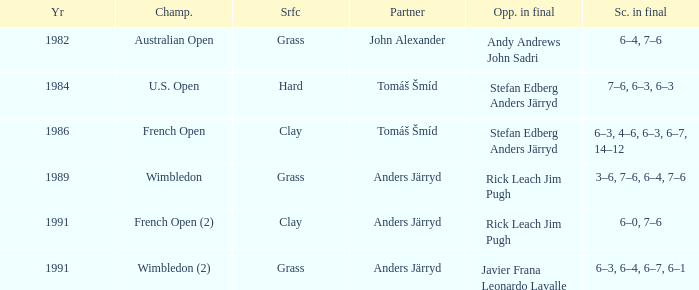What was the surface when he played with John Alexander?  Grass. 